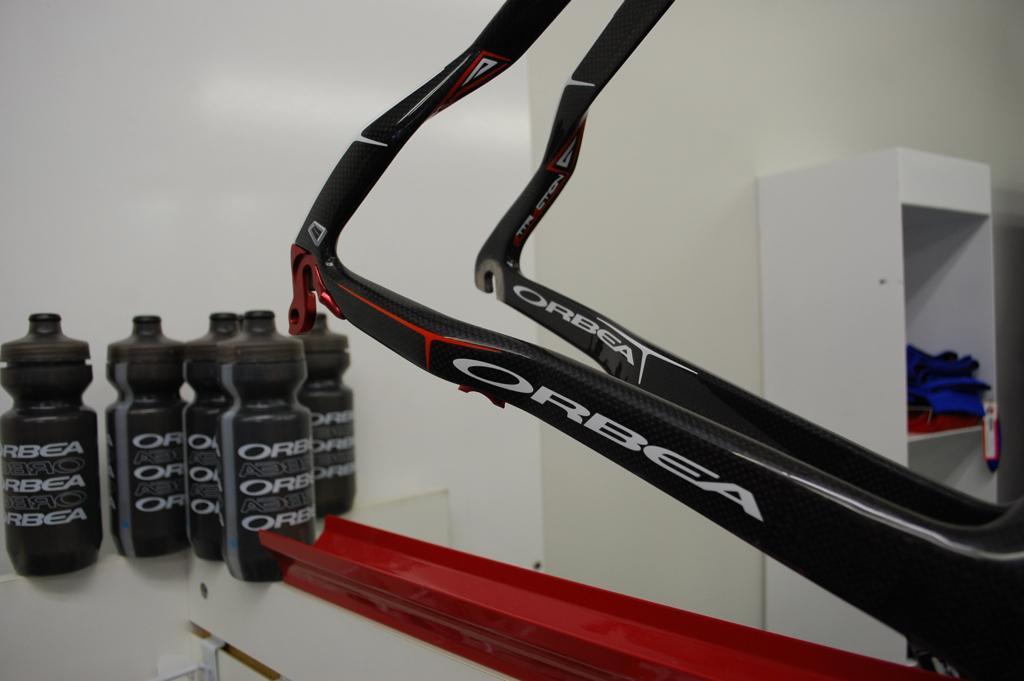Please provide a concise description of this image. Here in this picture we can see black color bottles on the wall. And black color holding object and a red color thing. To the right corner there is cupboard. Inside the cupboard there are some clothes. 